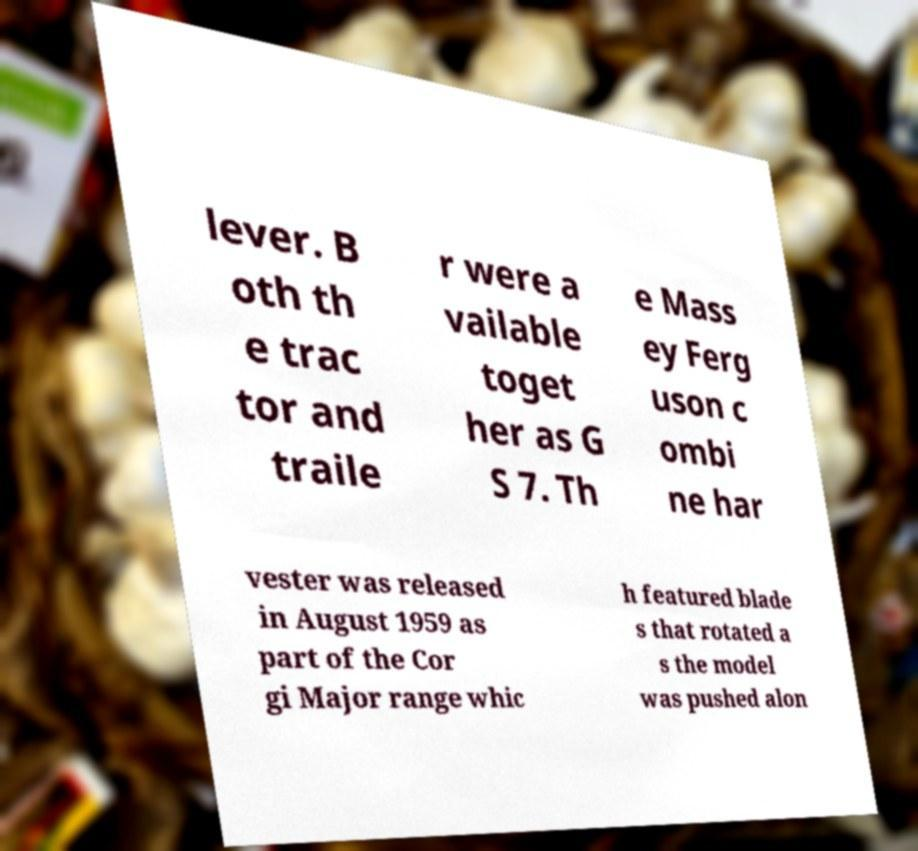Could you assist in decoding the text presented in this image and type it out clearly? lever. B oth th e trac tor and traile r were a vailable toget her as G S 7. Th e Mass ey Ferg uson c ombi ne har vester was released in August 1959 as part of the Cor gi Major range whic h featured blade s that rotated a s the model was pushed alon 